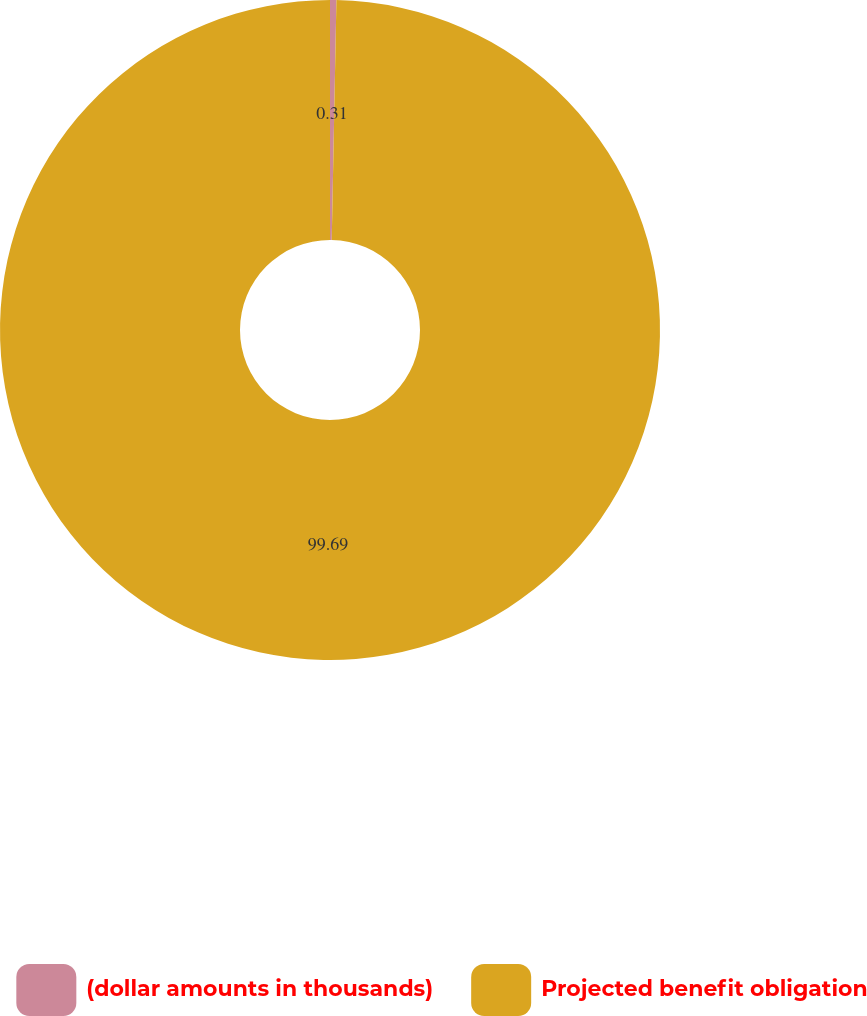Convert chart to OTSL. <chart><loc_0><loc_0><loc_500><loc_500><pie_chart><fcel>(dollar amounts in thousands)<fcel>Projected benefit obligation<nl><fcel>0.31%<fcel>99.69%<nl></chart> 